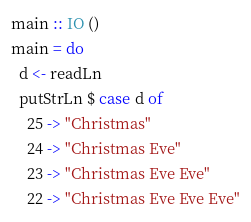Convert code to text. <code><loc_0><loc_0><loc_500><loc_500><_Haskell_>
main :: IO ()
main = do
  d <- readLn
  putStrLn $ case d of
    25 -> "Christmas"
    24 -> "Christmas Eve"
    23 -> "Christmas Eve Eve"
    22 -> "Christmas Eve Eve Eve"
</code> 